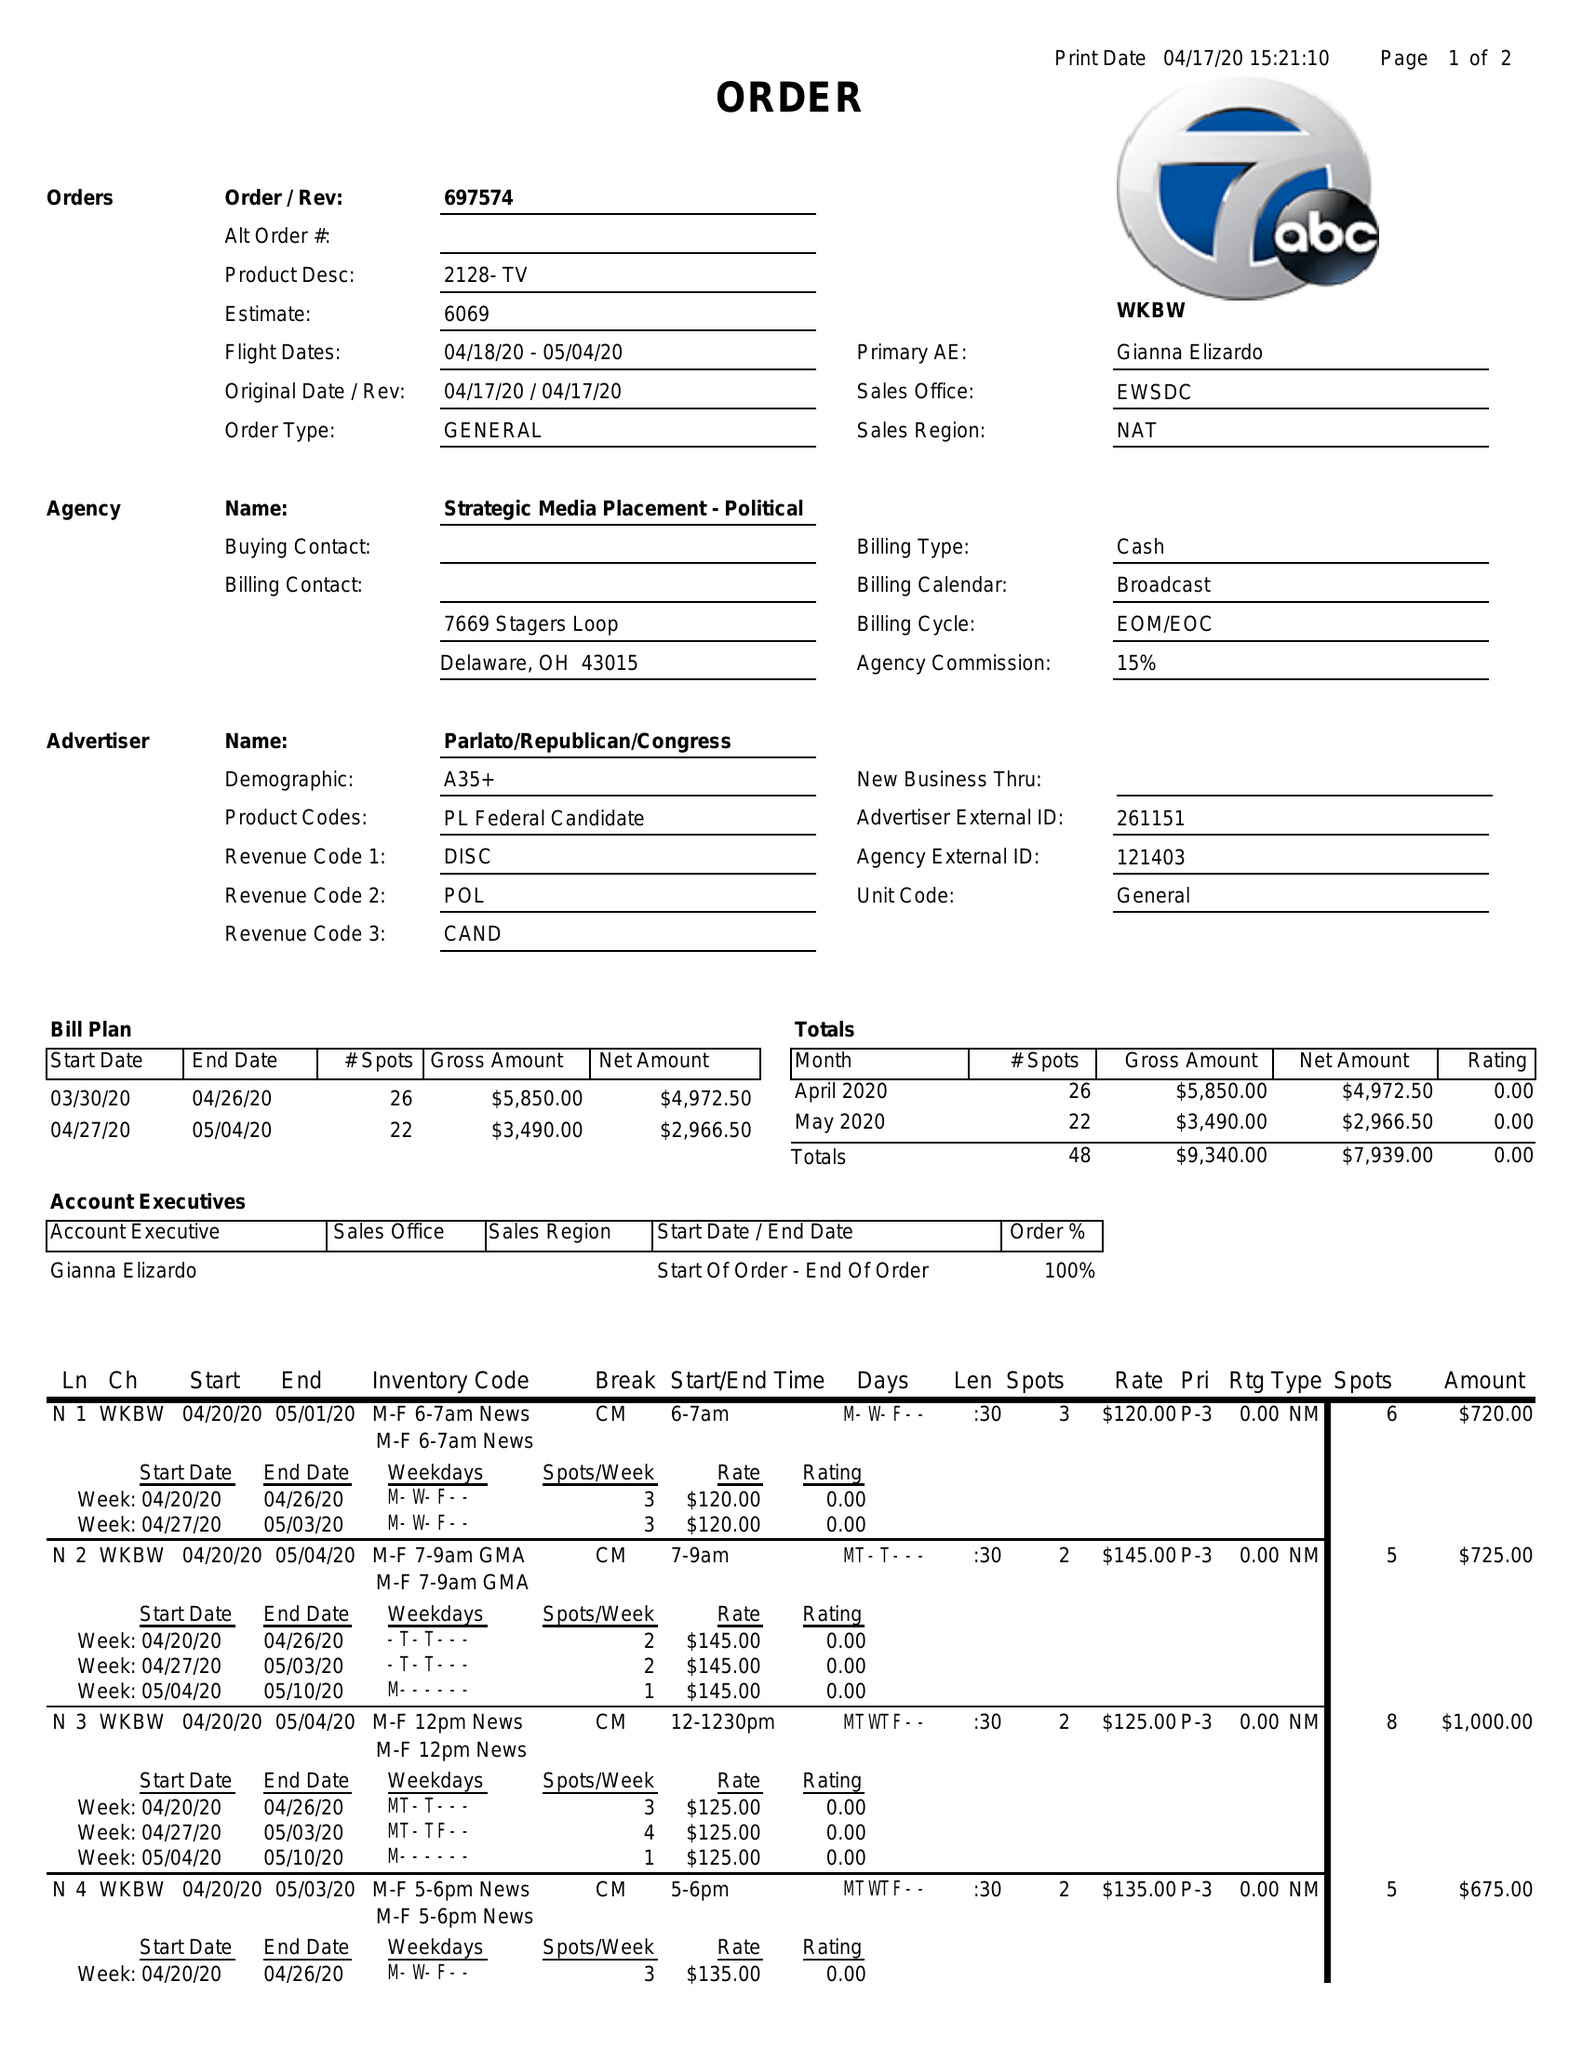What is the value for the flight_to?
Answer the question using a single word or phrase. 05/04/20 